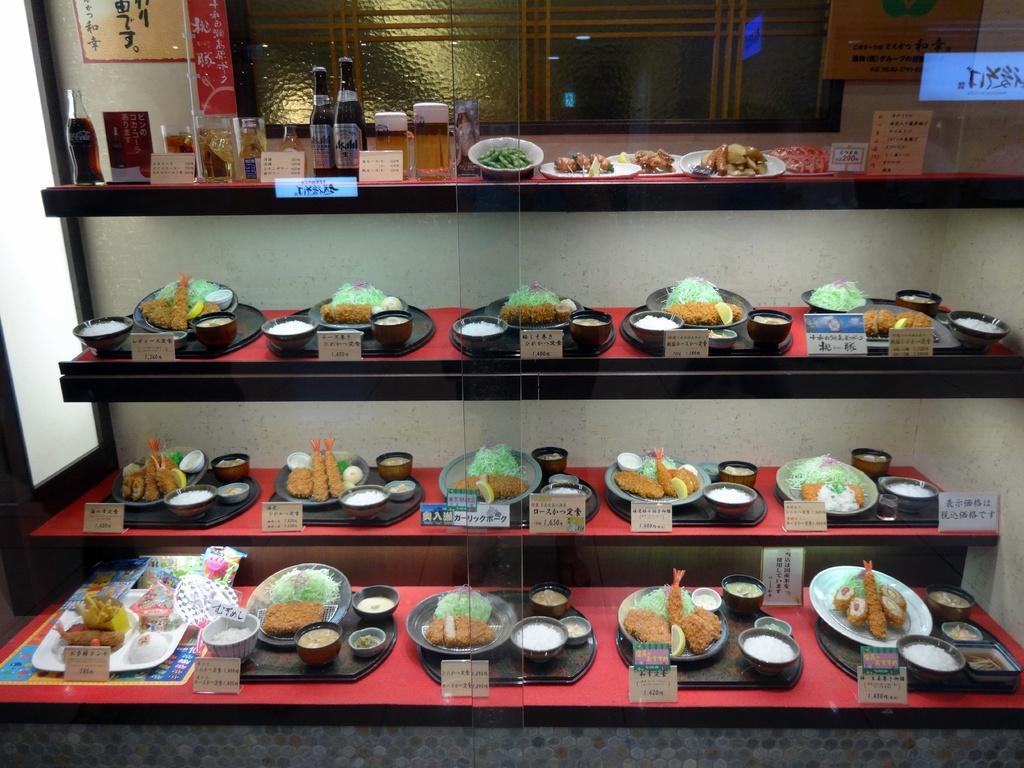Could you give a brief overview of what you see in this image? In the image there are some food items and drinks kept in the shelves and beside each food item there is name of dish and in the background there is a wall. 